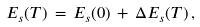<formula> <loc_0><loc_0><loc_500><loc_500>E _ { s } ( T ) \, = \, E _ { s } ( 0 ) \, + \, \Delta E _ { s } ( T ) \, ,</formula> 